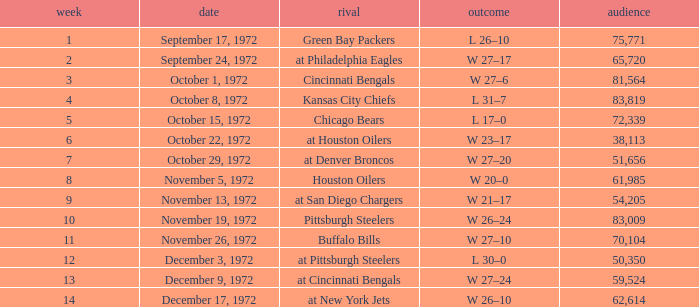What is the sum of week number(s) had an attendance of 61,985? 1.0. 